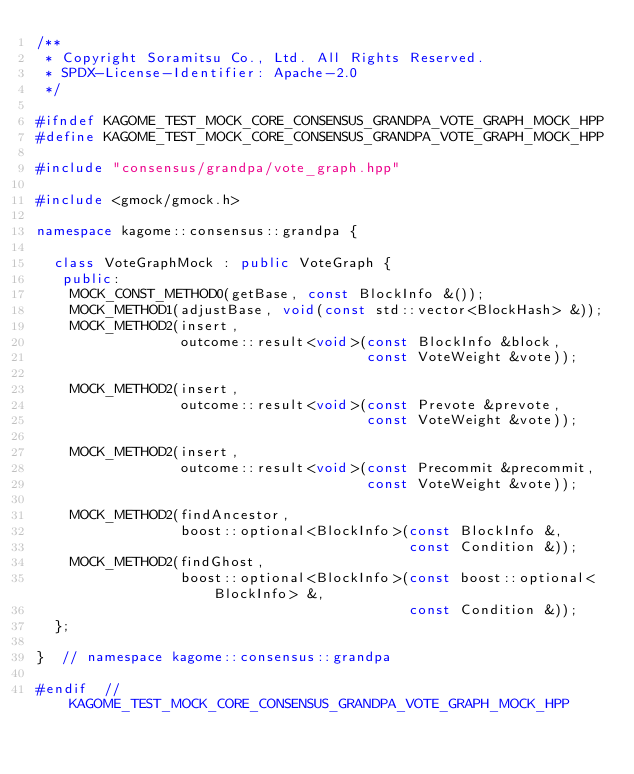<code> <loc_0><loc_0><loc_500><loc_500><_C++_>/**
 * Copyright Soramitsu Co., Ltd. All Rights Reserved.
 * SPDX-License-Identifier: Apache-2.0
 */

#ifndef KAGOME_TEST_MOCK_CORE_CONSENSUS_GRANDPA_VOTE_GRAPH_MOCK_HPP
#define KAGOME_TEST_MOCK_CORE_CONSENSUS_GRANDPA_VOTE_GRAPH_MOCK_HPP

#include "consensus/grandpa/vote_graph.hpp"

#include <gmock/gmock.h>

namespace kagome::consensus::grandpa {

  class VoteGraphMock : public VoteGraph {
   public:
    MOCK_CONST_METHOD0(getBase, const BlockInfo &());
    MOCK_METHOD1(adjustBase, void(const std::vector<BlockHash> &));
    MOCK_METHOD2(insert,
                 outcome::result<void>(const BlockInfo &block,
                                       const VoteWeight &vote));

    MOCK_METHOD2(insert,
                 outcome::result<void>(const Prevote &prevote,
                                       const VoteWeight &vote));

    MOCK_METHOD2(insert,
                 outcome::result<void>(const Precommit &precommit,
                                       const VoteWeight &vote));

    MOCK_METHOD2(findAncestor,
                 boost::optional<BlockInfo>(const BlockInfo &,
                                            const Condition &));
    MOCK_METHOD2(findGhost,
                 boost::optional<BlockInfo>(const boost::optional<BlockInfo> &,
                                            const Condition &));
  };

}  // namespace kagome::consensus::grandpa

#endif  // KAGOME_TEST_MOCK_CORE_CONSENSUS_GRANDPA_VOTE_GRAPH_MOCK_HPP
</code> 